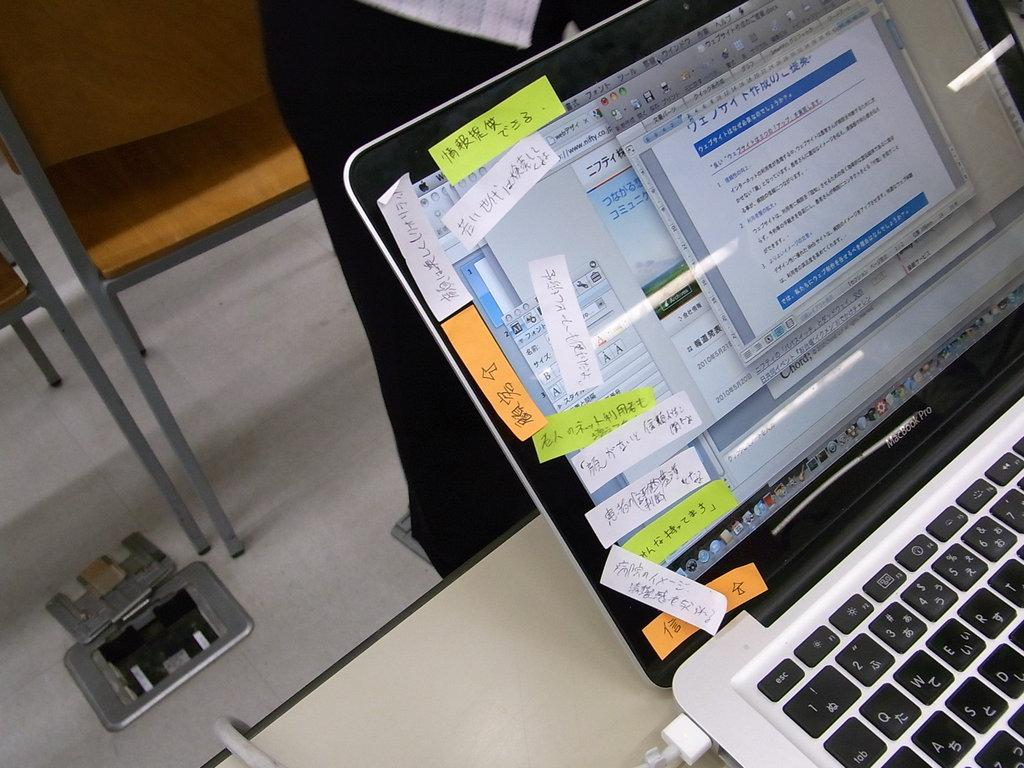<image>
Present a compact description of the photo's key features. Macbook Pro computer monitor showing many stickers on the left side. 